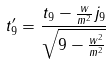Convert formula to latex. <formula><loc_0><loc_0><loc_500><loc_500>t _ { 9 } ^ { \prime } = \frac { t _ { 9 } - \frac { w } { m ^ { 2 } } j _ { 9 } } { \sqrt { 9 - \frac { w ^ { 2 } } { m ^ { 2 } } } }</formula> 